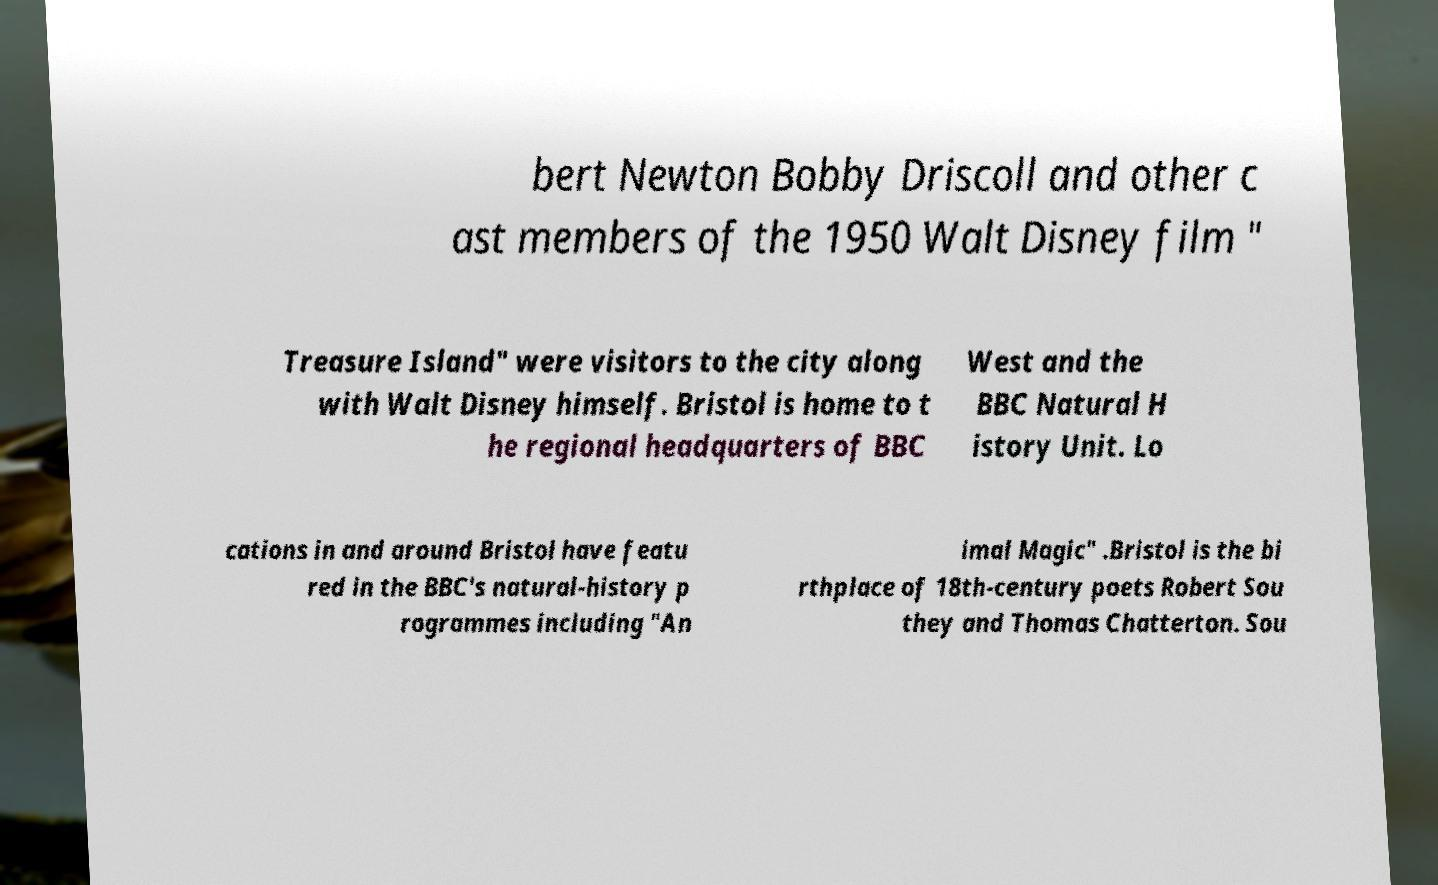Can you read and provide the text displayed in the image?This photo seems to have some interesting text. Can you extract and type it out for me? bert Newton Bobby Driscoll and other c ast members of the 1950 Walt Disney film " Treasure Island" were visitors to the city along with Walt Disney himself. Bristol is home to t he regional headquarters of BBC West and the BBC Natural H istory Unit. Lo cations in and around Bristol have featu red in the BBC's natural-history p rogrammes including "An imal Magic" .Bristol is the bi rthplace of 18th-century poets Robert Sou they and Thomas Chatterton. Sou 